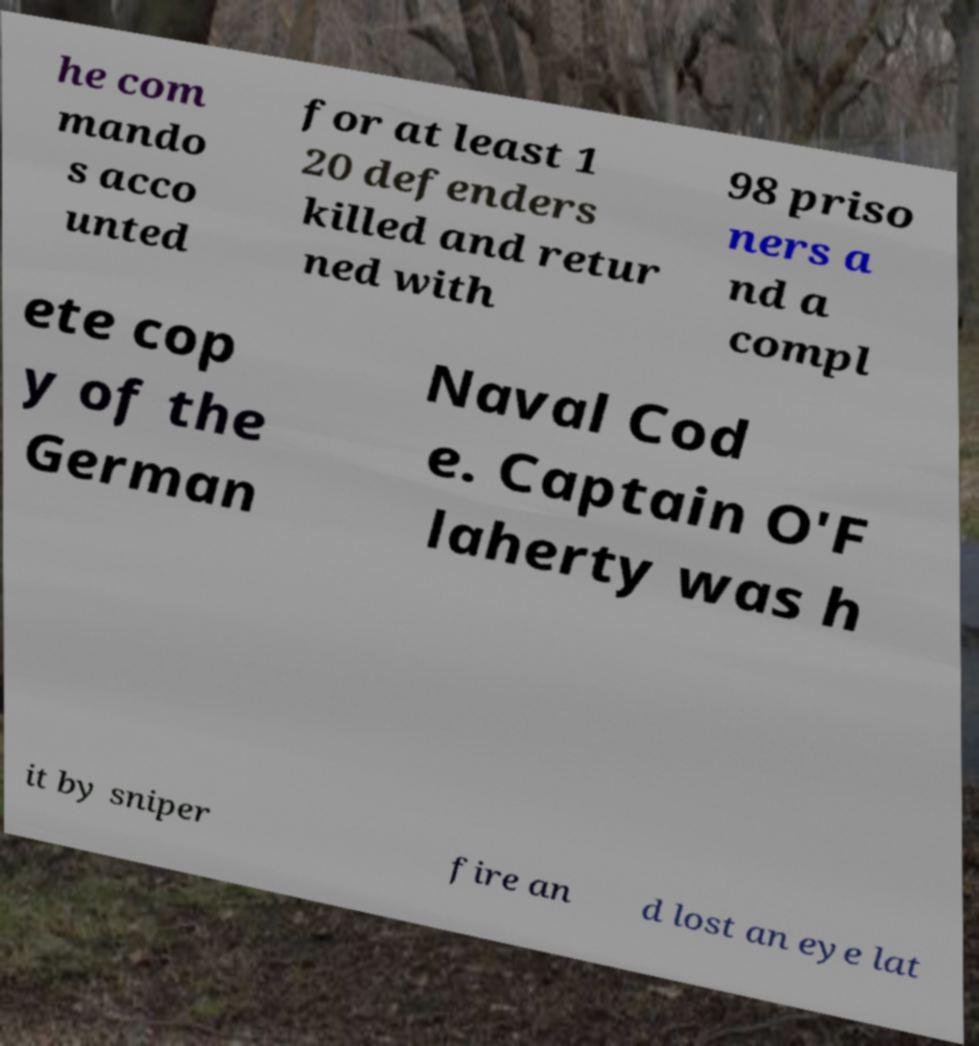Please read and relay the text visible in this image. What does it say? he com mando s acco unted for at least 1 20 defenders killed and retur ned with 98 priso ners a nd a compl ete cop y of the German Naval Cod e. Captain O'F laherty was h it by sniper fire an d lost an eye lat 